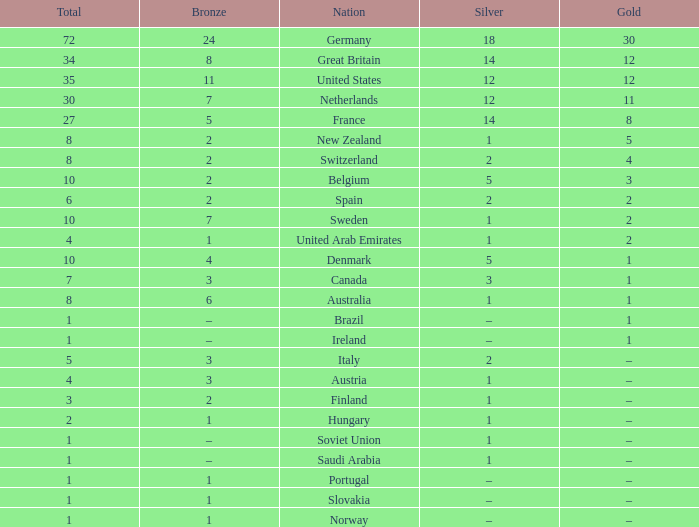What is the total number of Total, when Silver is 1, and when Bronze is 7? 1.0. 